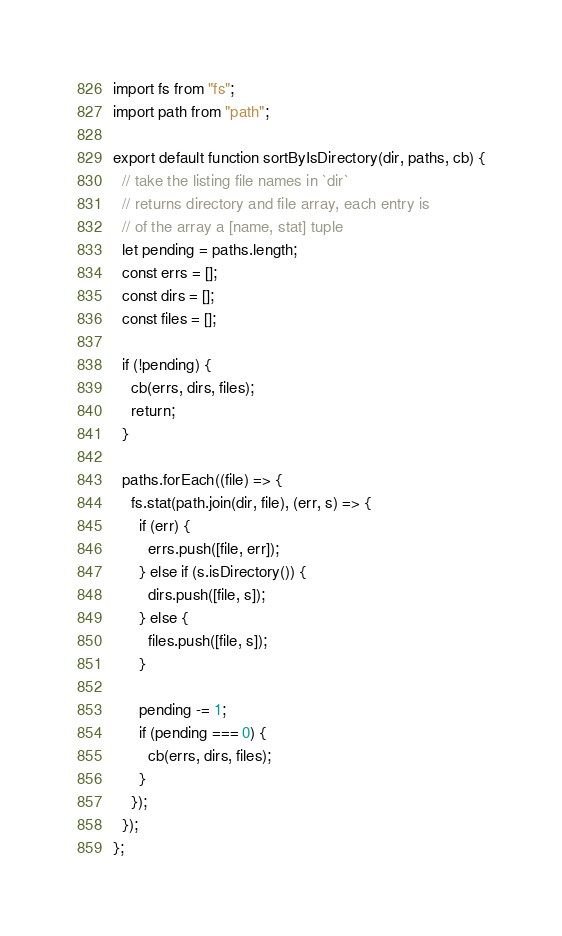Convert code to text. <code><loc_0><loc_0><loc_500><loc_500><_JavaScript_>import fs from "fs";
import path from "path";

export default function sortByIsDirectory(dir, paths, cb) {
  // take the listing file names in `dir`
  // returns directory and file array, each entry is
  // of the array a [name, stat] tuple
  let pending = paths.length;
  const errs = [];
  const dirs = [];
  const files = [];

  if (!pending) {
    cb(errs, dirs, files);
    return;
  }

  paths.forEach((file) => {
    fs.stat(path.join(dir, file), (err, s) => {
      if (err) {
        errs.push([file, err]);
      } else if (s.isDirectory()) {
        dirs.push([file, s]);
      } else {
        files.push([file, s]);
      }

      pending -= 1;
      if (pending === 0) {
        cb(errs, dirs, files);
      }
    });
  });
};

</code> 